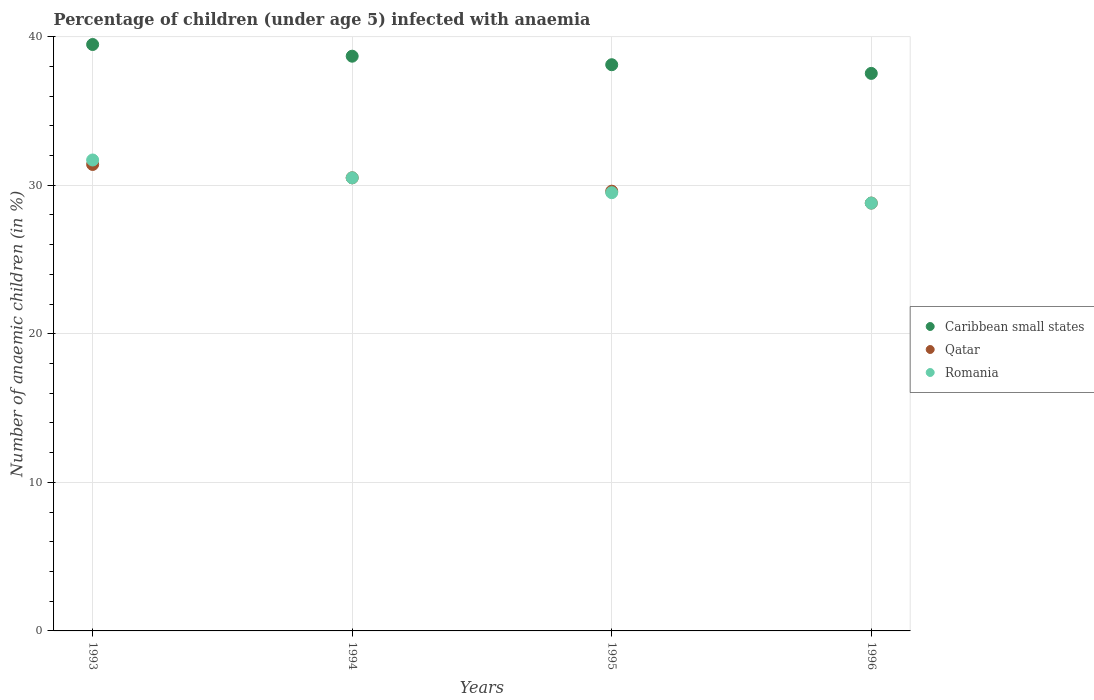How many different coloured dotlines are there?
Offer a terse response. 3. What is the percentage of children infected with anaemia in in Qatar in 1995?
Give a very brief answer. 29.6. Across all years, what is the maximum percentage of children infected with anaemia in in Romania?
Provide a short and direct response. 31.7. Across all years, what is the minimum percentage of children infected with anaemia in in Qatar?
Keep it short and to the point. 28.8. In which year was the percentage of children infected with anaemia in in Caribbean small states maximum?
Give a very brief answer. 1993. What is the total percentage of children infected with anaemia in in Romania in the graph?
Keep it short and to the point. 120.5. What is the difference between the percentage of children infected with anaemia in in Caribbean small states in 1993 and that in 1996?
Make the answer very short. 1.94. What is the difference between the percentage of children infected with anaemia in in Caribbean small states in 1994 and the percentage of children infected with anaemia in in Qatar in 1995?
Your answer should be compact. 9.09. What is the average percentage of children infected with anaemia in in Caribbean small states per year?
Offer a terse response. 38.45. In the year 1993, what is the difference between the percentage of children infected with anaemia in in Qatar and percentage of children infected with anaemia in in Romania?
Your response must be concise. -0.3. What is the ratio of the percentage of children infected with anaemia in in Caribbean small states in 1994 to that in 1996?
Provide a succinct answer. 1.03. Is the percentage of children infected with anaemia in in Romania in 1995 less than that in 1996?
Ensure brevity in your answer.  No. Is the difference between the percentage of children infected with anaemia in in Qatar in 1993 and 1995 greater than the difference between the percentage of children infected with anaemia in in Romania in 1993 and 1995?
Keep it short and to the point. No. What is the difference between the highest and the second highest percentage of children infected with anaemia in in Romania?
Make the answer very short. 1.2. What is the difference between the highest and the lowest percentage of children infected with anaemia in in Qatar?
Your answer should be compact. 2.6. In how many years, is the percentage of children infected with anaemia in in Caribbean small states greater than the average percentage of children infected with anaemia in in Caribbean small states taken over all years?
Offer a very short reply. 2. Does the percentage of children infected with anaemia in in Romania monotonically increase over the years?
Your answer should be very brief. No. Is the percentage of children infected with anaemia in in Caribbean small states strictly greater than the percentage of children infected with anaemia in in Qatar over the years?
Offer a terse response. Yes. How many dotlines are there?
Provide a succinct answer. 3. How many years are there in the graph?
Your answer should be very brief. 4. Are the values on the major ticks of Y-axis written in scientific E-notation?
Offer a very short reply. No. Does the graph contain any zero values?
Offer a terse response. No. Does the graph contain grids?
Provide a short and direct response. Yes. Where does the legend appear in the graph?
Keep it short and to the point. Center right. How many legend labels are there?
Provide a succinct answer. 3. How are the legend labels stacked?
Provide a short and direct response. Vertical. What is the title of the graph?
Make the answer very short. Percentage of children (under age 5) infected with anaemia. What is the label or title of the X-axis?
Give a very brief answer. Years. What is the label or title of the Y-axis?
Your answer should be very brief. Number of anaemic children (in %). What is the Number of anaemic children (in %) of Caribbean small states in 1993?
Provide a succinct answer. 39.47. What is the Number of anaemic children (in %) in Qatar in 1993?
Give a very brief answer. 31.4. What is the Number of anaemic children (in %) in Romania in 1993?
Keep it short and to the point. 31.7. What is the Number of anaemic children (in %) in Caribbean small states in 1994?
Give a very brief answer. 38.69. What is the Number of anaemic children (in %) of Qatar in 1994?
Ensure brevity in your answer.  30.5. What is the Number of anaemic children (in %) in Romania in 1994?
Give a very brief answer. 30.5. What is the Number of anaemic children (in %) in Caribbean small states in 1995?
Offer a very short reply. 38.11. What is the Number of anaemic children (in %) in Qatar in 1995?
Make the answer very short. 29.6. What is the Number of anaemic children (in %) in Romania in 1995?
Offer a terse response. 29.5. What is the Number of anaemic children (in %) in Caribbean small states in 1996?
Your response must be concise. 37.53. What is the Number of anaemic children (in %) of Qatar in 1996?
Offer a terse response. 28.8. What is the Number of anaemic children (in %) of Romania in 1996?
Your answer should be very brief. 28.8. Across all years, what is the maximum Number of anaemic children (in %) in Caribbean small states?
Your answer should be compact. 39.47. Across all years, what is the maximum Number of anaemic children (in %) in Qatar?
Make the answer very short. 31.4. Across all years, what is the maximum Number of anaemic children (in %) in Romania?
Ensure brevity in your answer.  31.7. Across all years, what is the minimum Number of anaemic children (in %) of Caribbean small states?
Give a very brief answer. 37.53. Across all years, what is the minimum Number of anaemic children (in %) of Qatar?
Offer a terse response. 28.8. Across all years, what is the minimum Number of anaemic children (in %) of Romania?
Give a very brief answer. 28.8. What is the total Number of anaemic children (in %) in Caribbean small states in the graph?
Your response must be concise. 153.8. What is the total Number of anaemic children (in %) of Qatar in the graph?
Provide a short and direct response. 120.3. What is the total Number of anaemic children (in %) in Romania in the graph?
Your response must be concise. 120.5. What is the difference between the Number of anaemic children (in %) in Caribbean small states in 1993 and that in 1994?
Your answer should be compact. 0.79. What is the difference between the Number of anaemic children (in %) in Qatar in 1993 and that in 1994?
Your answer should be very brief. 0.9. What is the difference between the Number of anaemic children (in %) in Romania in 1993 and that in 1994?
Provide a succinct answer. 1.2. What is the difference between the Number of anaemic children (in %) of Caribbean small states in 1993 and that in 1995?
Provide a short and direct response. 1.36. What is the difference between the Number of anaemic children (in %) of Romania in 1993 and that in 1995?
Provide a succinct answer. 2.2. What is the difference between the Number of anaemic children (in %) in Caribbean small states in 1993 and that in 1996?
Give a very brief answer. 1.94. What is the difference between the Number of anaemic children (in %) in Qatar in 1993 and that in 1996?
Give a very brief answer. 2.6. What is the difference between the Number of anaemic children (in %) of Caribbean small states in 1994 and that in 1995?
Make the answer very short. 0.57. What is the difference between the Number of anaemic children (in %) in Caribbean small states in 1994 and that in 1996?
Make the answer very short. 1.16. What is the difference between the Number of anaemic children (in %) in Romania in 1994 and that in 1996?
Ensure brevity in your answer.  1.7. What is the difference between the Number of anaemic children (in %) of Caribbean small states in 1995 and that in 1996?
Ensure brevity in your answer.  0.58. What is the difference between the Number of anaemic children (in %) in Romania in 1995 and that in 1996?
Provide a succinct answer. 0.7. What is the difference between the Number of anaemic children (in %) in Caribbean small states in 1993 and the Number of anaemic children (in %) in Qatar in 1994?
Give a very brief answer. 8.97. What is the difference between the Number of anaemic children (in %) of Caribbean small states in 1993 and the Number of anaemic children (in %) of Romania in 1994?
Offer a very short reply. 8.97. What is the difference between the Number of anaemic children (in %) of Caribbean small states in 1993 and the Number of anaemic children (in %) of Qatar in 1995?
Provide a succinct answer. 9.87. What is the difference between the Number of anaemic children (in %) in Caribbean small states in 1993 and the Number of anaemic children (in %) in Romania in 1995?
Give a very brief answer. 9.97. What is the difference between the Number of anaemic children (in %) in Qatar in 1993 and the Number of anaemic children (in %) in Romania in 1995?
Give a very brief answer. 1.9. What is the difference between the Number of anaemic children (in %) of Caribbean small states in 1993 and the Number of anaemic children (in %) of Qatar in 1996?
Your response must be concise. 10.67. What is the difference between the Number of anaemic children (in %) of Caribbean small states in 1993 and the Number of anaemic children (in %) of Romania in 1996?
Offer a very short reply. 10.67. What is the difference between the Number of anaemic children (in %) of Caribbean small states in 1994 and the Number of anaemic children (in %) of Qatar in 1995?
Your answer should be very brief. 9.09. What is the difference between the Number of anaemic children (in %) of Caribbean small states in 1994 and the Number of anaemic children (in %) of Romania in 1995?
Offer a terse response. 9.19. What is the difference between the Number of anaemic children (in %) in Qatar in 1994 and the Number of anaemic children (in %) in Romania in 1995?
Make the answer very short. 1. What is the difference between the Number of anaemic children (in %) in Caribbean small states in 1994 and the Number of anaemic children (in %) in Qatar in 1996?
Keep it short and to the point. 9.89. What is the difference between the Number of anaemic children (in %) of Caribbean small states in 1994 and the Number of anaemic children (in %) of Romania in 1996?
Keep it short and to the point. 9.89. What is the difference between the Number of anaemic children (in %) in Caribbean small states in 1995 and the Number of anaemic children (in %) in Qatar in 1996?
Your answer should be very brief. 9.31. What is the difference between the Number of anaemic children (in %) of Caribbean small states in 1995 and the Number of anaemic children (in %) of Romania in 1996?
Offer a very short reply. 9.31. What is the average Number of anaemic children (in %) in Caribbean small states per year?
Your answer should be very brief. 38.45. What is the average Number of anaemic children (in %) of Qatar per year?
Ensure brevity in your answer.  30.07. What is the average Number of anaemic children (in %) of Romania per year?
Give a very brief answer. 30.12. In the year 1993, what is the difference between the Number of anaemic children (in %) of Caribbean small states and Number of anaemic children (in %) of Qatar?
Your answer should be very brief. 8.07. In the year 1993, what is the difference between the Number of anaemic children (in %) in Caribbean small states and Number of anaemic children (in %) in Romania?
Provide a short and direct response. 7.77. In the year 1993, what is the difference between the Number of anaemic children (in %) of Qatar and Number of anaemic children (in %) of Romania?
Offer a very short reply. -0.3. In the year 1994, what is the difference between the Number of anaemic children (in %) in Caribbean small states and Number of anaemic children (in %) in Qatar?
Ensure brevity in your answer.  8.19. In the year 1994, what is the difference between the Number of anaemic children (in %) in Caribbean small states and Number of anaemic children (in %) in Romania?
Your answer should be very brief. 8.19. In the year 1995, what is the difference between the Number of anaemic children (in %) of Caribbean small states and Number of anaemic children (in %) of Qatar?
Keep it short and to the point. 8.51. In the year 1995, what is the difference between the Number of anaemic children (in %) of Caribbean small states and Number of anaemic children (in %) of Romania?
Offer a very short reply. 8.61. In the year 1995, what is the difference between the Number of anaemic children (in %) in Qatar and Number of anaemic children (in %) in Romania?
Ensure brevity in your answer.  0.1. In the year 1996, what is the difference between the Number of anaemic children (in %) in Caribbean small states and Number of anaemic children (in %) in Qatar?
Provide a succinct answer. 8.73. In the year 1996, what is the difference between the Number of anaemic children (in %) in Caribbean small states and Number of anaemic children (in %) in Romania?
Offer a terse response. 8.73. What is the ratio of the Number of anaemic children (in %) of Caribbean small states in 1993 to that in 1994?
Provide a succinct answer. 1.02. What is the ratio of the Number of anaemic children (in %) of Qatar in 1993 to that in 1994?
Provide a succinct answer. 1.03. What is the ratio of the Number of anaemic children (in %) in Romania in 1993 to that in 1994?
Ensure brevity in your answer.  1.04. What is the ratio of the Number of anaemic children (in %) in Caribbean small states in 1993 to that in 1995?
Your answer should be compact. 1.04. What is the ratio of the Number of anaemic children (in %) of Qatar in 1993 to that in 1995?
Provide a short and direct response. 1.06. What is the ratio of the Number of anaemic children (in %) of Romania in 1993 to that in 1995?
Ensure brevity in your answer.  1.07. What is the ratio of the Number of anaemic children (in %) of Caribbean small states in 1993 to that in 1996?
Your answer should be compact. 1.05. What is the ratio of the Number of anaemic children (in %) in Qatar in 1993 to that in 1996?
Provide a succinct answer. 1.09. What is the ratio of the Number of anaemic children (in %) of Romania in 1993 to that in 1996?
Make the answer very short. 1.1. What is the ratio of the Number of anaemic children (in %) in Caribbean small states in 1994 to that in 1995?
Your answer should be very brief. 1.02. What is the ratio of the Number of anaemic children (in %) in Qatar in 1994 to that in 1995?
Offer a very short reply. 1.03. What is the ratio of the Number of anaemic children (in %) of Romania in 1994 to that in 1995?
Offer a terse response. 1.03. What is the ratio of the Number of anaemic children (in %) in Caribbean small states in 1994 to that in 1996?
Ensure brevity in your answer.  1.03. What is the ratio of the Number of anaemic children (in %) of Qatar in 1994 to that in 1996?
Your response must be concise. 1.06. What is the ratio of the Number of anaemic children (in %) in Romania in 1994 to that in 1996?
Give a very brief answer. 1.06. What is the ratio of the Number of anaemic children (in %) in Caribbean small states in 1995 to that in 1996?
Your answer should be very brief. 1.02. What is the ratio of the Number of anaemic children (in %) in Qatar in 1995 to that in 1996?
Ensure brevity in your answer.  1.03. What is the ratio of the Number of anaemic children (in %) of Romania in 1995 to that in 1996?
Give a very brief answer. 1.02. What is the difference between the highest and the second highest Number of anaemic children (in %) in Caribbean small states?
Keep it short and to the point. 0.79. What is the difference between the highest and the second highest Number of anaemic children (in %) of Qatar?
Offer a very short reply. 0.9. What is the difference between the highest and the lowest Number of anaemic children (in %) in Caribbean small states?
Provide a succinct answer. 1.94. What is the difference between the highest and the lowest Number of anaemic children (in %) of Qatar?
Ensure brevity in your answer.  2.6. What is the difference between the highest and the lowest Number of anaemic children (in %) of Romania?
Make the answer very short. 2.9. 